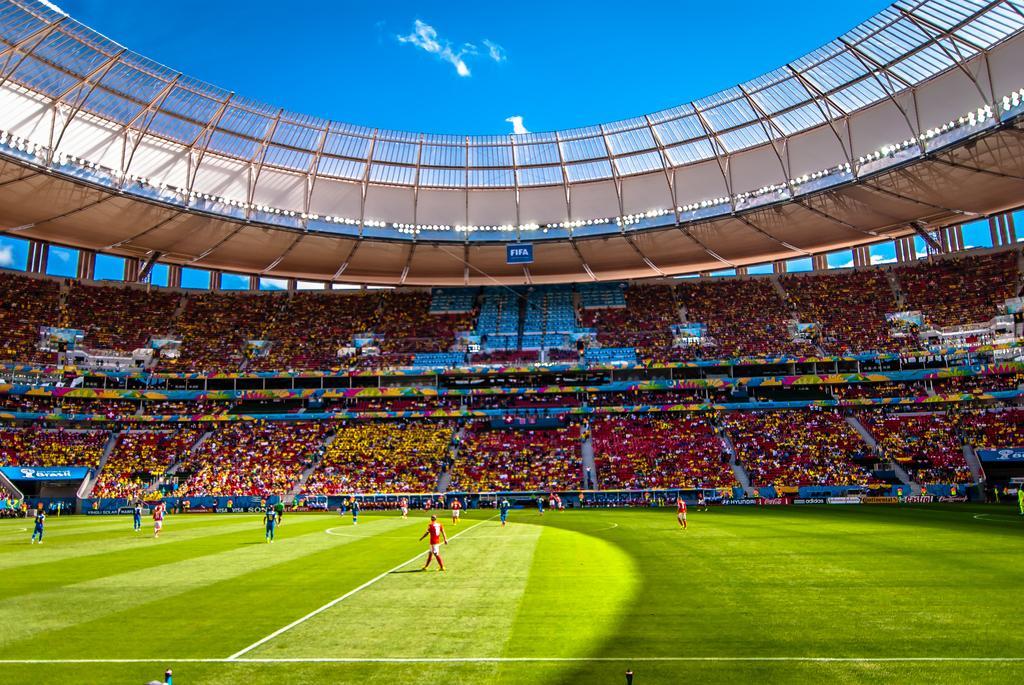Can you describe this image briefly? In the image I can see a stadium. I can also see people on the ground and a group of people are sitting on chairs, the sky and some other objects on the ground. I can see the grass and white lines on the ground. 